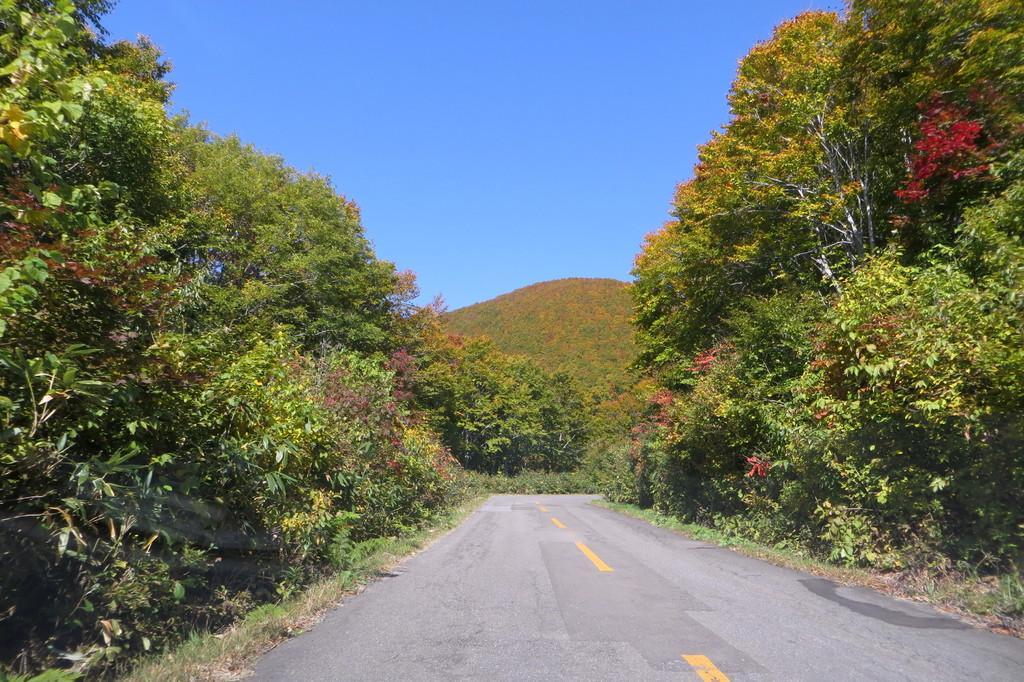Describe this image in one or two sentences. In this image we can see a road. On the sides of the road there are trees. In the back there is hill. Also there is sky. 